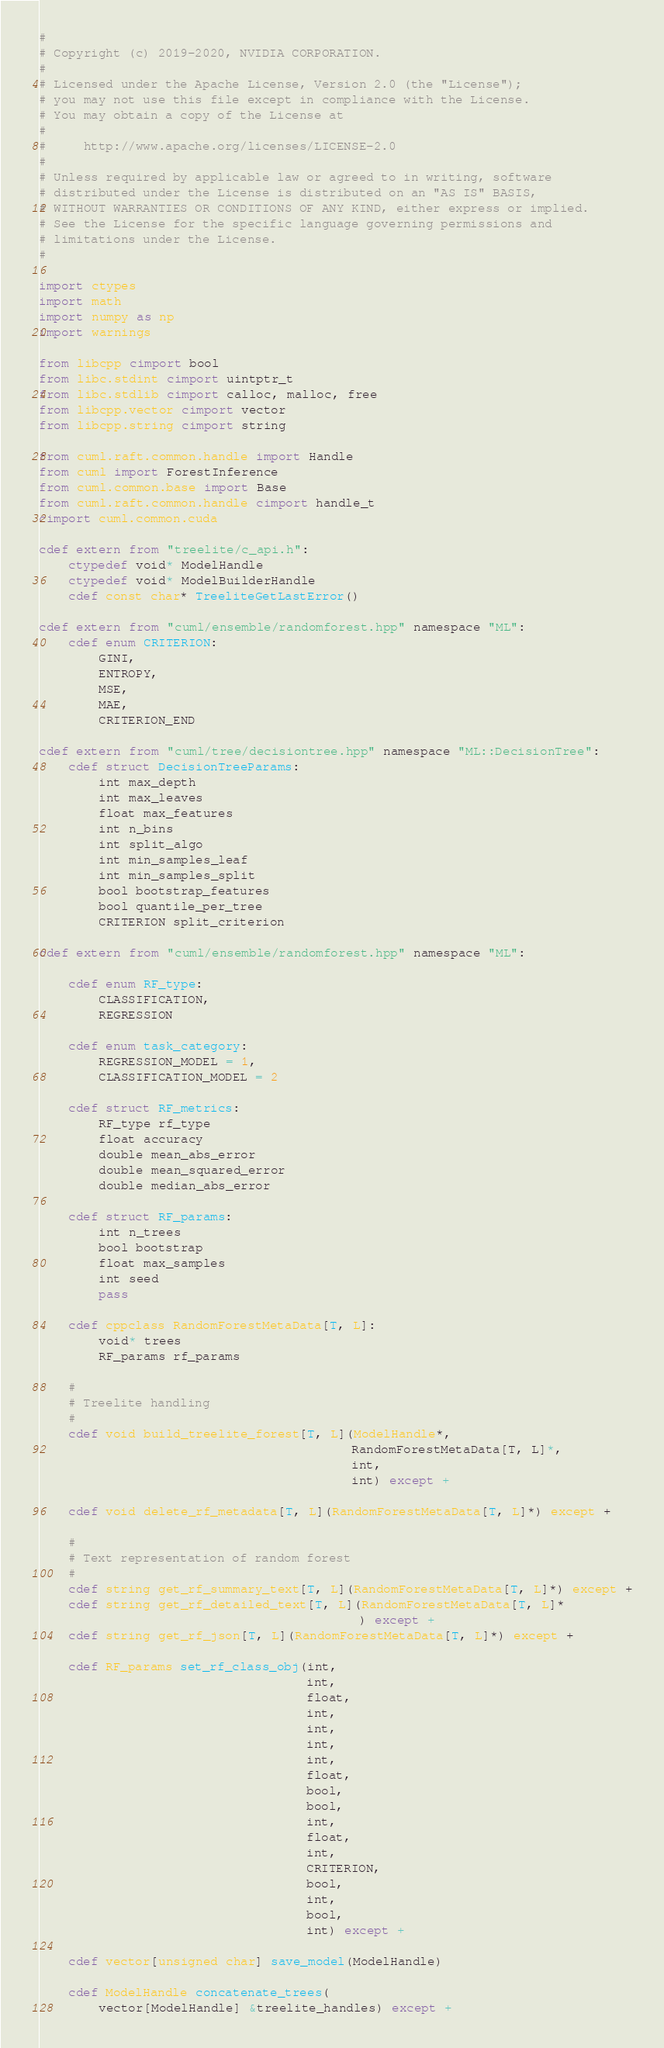<code> <loc_0><loc_0><loc_500><loc_500><_Cython_>#
# Copyright (c) 2019-2020, NVIDIA CORPORATION.
#
# Licensed under the Apache License, Version 2.0 (the "License");
# you may not use this file except in compliance with the License.
# You may obtain a copy of the License at
#
#     http://www.apache.org/licenses/LICENSE-2.0
#
# Unless required by applicable law or agreed to in writing, software
# distributed under the License is distributed on an "AS IS" BASIS,
# WITHOUT WARRANTIES OR CONDITIONS OF ANY KIND, either express or implied.
# See the License for the specific language governing permissions and
# limitations under the License.
#

import ctypes
import math
import numpy as np
import warnings

from libcpp cimport bool
from libc.stdint cimport uintptr_t
from libc.stdlib cimport calloc, malloc, free
from libcpp.vector cimport vector
from libcpp.string cimport string

from cuml.raft.common.handle import Handle
from cuml import ForestInference
from cuml.common.base import Base
from cuml.raft.common.handle cimport handle_t
cimport cuml.common.cuda

cdef extern from "treelite/c_api.h":
    ctypedef void* ModelHandle
    ctypedef void* ModelBuilderHandle
    cdef const char* TreeliteGetLastError()

cdef extern from "cuml/ensemble/randomforest.hpp" namespace "ML":
    cdef enum CRITERION:
        GINI,
        ENTROPY,
        MSE,
        MAE,
        CRITERION_END

cdef extern from "cuml/tree/decisiontree.hpp" namespace "ML::DecisionTree":
    cdef struct DecisionTreeParams:
        int max_depth
        int max_leaves
        float max_features
        int n_bins
        int split_algo
        int min_samples_leaf
        int min_samples_split
        bool bootstrap_features
        bool quantile_per_tree
        CRITERION split_criterion

cdef extern from "cuml/ensemble/randomforest.hpp" namespace "ML":

    cdef enum RF_type:
        CLASSIFICATION,
        REGRESSION

    cdef enum task_category:
        REGRESSION_MODEL = 1,
        CLASSIFICATION_MODEL = 2

    cdef struct RF_metrics:
        RF_type rf_type
        float accuracy
        double mean_abs_error
        double mean_squared_error
        double median_abs_error

    cdef struct RF_params:
        int n_trees
        bool bootstrap
        float max_samples
        int seed
        pass

    cdef cppclass RandomForestMetaData[T, L]:
        void* trees
        RF_params rf_params

    #
    # Treelite handling
    #
    cdef void build_treelite_forest[T, L](ModelHandle*,
                                          RandomForestMetaData[T, L]*,
                                          int,
                                          int) except +

    cdef void delete_rf_metadata[T, L](RandomForestMetaData[T, L]*) except +

    #
    # Text representation of random forest
    #
    cdef string get_rf_summary_text[T, L](RandomForestMetaData[T, L]*) except +
    cdef string get_rf_detailed_text[T, L](RandomForestMetaData[T, L]*
                                           ) except +
    cdef string get_rf_json[T, L](RandomForestMetaData[T, L]*) except +

    cdef RF_params set_rf_class_obj(int,
                                    int,
                                    float,
                                    int,
                                    int,
                                    int,
                                    int,
                                    float,
                                    bool,
                                    bool,
                                    int,
                                    float,
                                    int,
                                    CRITERION,
                                    bool,
                                    int,
                                    bool,
                                    int) except +

    cdef vector[unsigned char] save_model(ModelHandle)

    cdef ModelHandle concatenate_trees(
        vector[ModelHandle] &treelite_handles) except +
</code> 